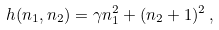<formula> <loc_0><loc_0><loc_500><loc_500>h ( n _ { 1 } , n _ { 2 } ) = \gamma n _ { 1 } ^ { 2 } + ( n _ { 2 } + 1 ) ^ { 2 } \, ,</formula> 